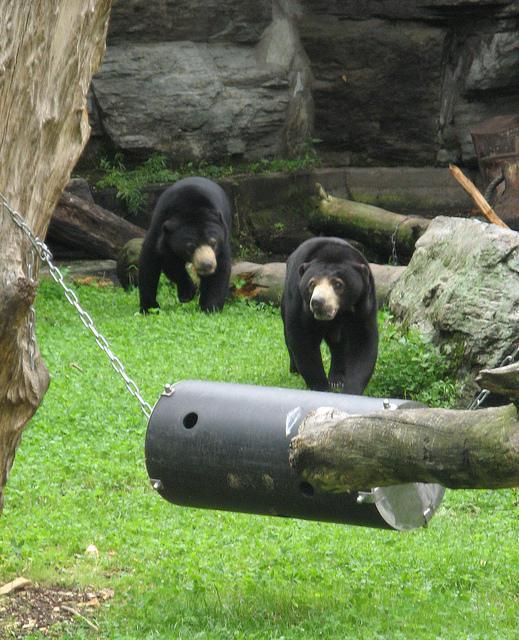How many animals are in this picture?
Give a very brief answer. 2. How many bears can be seen?
Give a very brief answer. 2. 